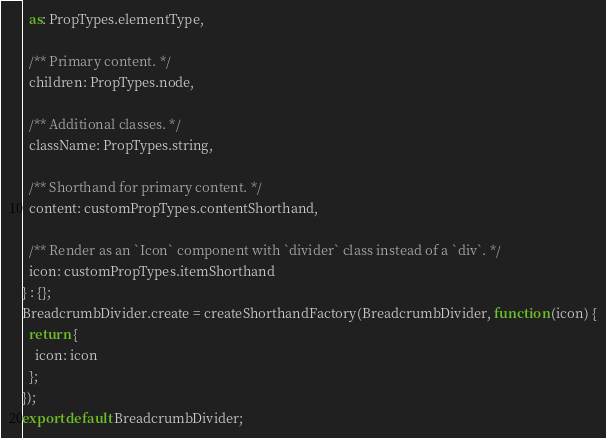<code> <loc_0><loc_0><loc_500><loc_500><_JavaScript_>  as: PropTypes.elementType,

  /** Primary content. */
  children: PropTypes.node,

  /** Additional classes. */
  className: PropTypes.string,

  /** Shorthand for primary content. */
  content: customPropTypes.contentShorthand,

  /** Render as an `Icon` component with `divider` class instead of a `div`. */
  icon: customPropTypes.itemShorthand
} : {};
BreadcrumbDivider.create = createShorthandFactory(BreadcrumbDivider, function (icon) {
  return {
    icon: icon
  };
});
export default BreadcrumbDivider;</code> 